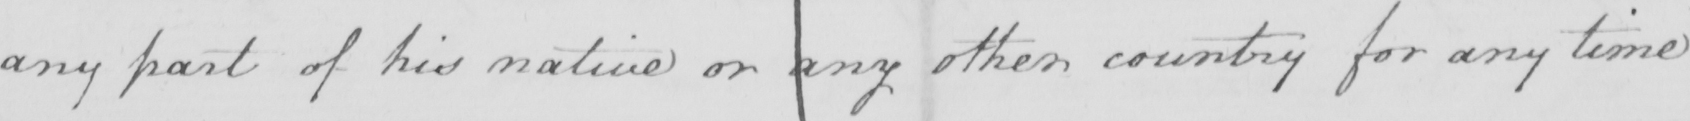What is written in this line of handwriting? any part of his native or any other country for any time 